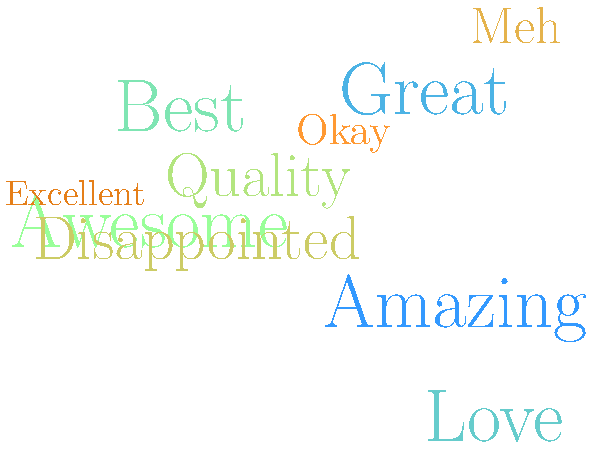As an intern researching trendy products for an influencer, you've conducted a brand sentiment analysis for a potential product collaboration. The word cloud above represents the most frequent words used in customer reviews. Which sentiment appears to be the most prominent, and how might this information guide your recommendation to the influencer? To answer this question, we need to analyze the word cloud systematically:

1. Identify the largest words: The most prominent words in a word cloud are typically represented by larger font sizes. In this case, "Amazing" and "Great" appear to be the largest.

2. Assess the overall sentiment: Most of the prominent words are positive (e.g., "Amazing", "Great", "Love", "Best", "Awesome", "Quality", "Excellent").

3. Note any negative sentiment: There are a few less prominent words with negative or neutral connotations (e.g., "Disappointed", "Meh", "Okay"), but they are smaller in size, indicating less frequency.

4. Interpret the results: The overwhelming presence of positive words, especially "Amazing" and "Great" being the largest, suggests that the overall sentiment towards this brand or product is very positive.

5. Consider the implications: For an influencer collaboration, a brand with strongly positive sentiment is likely to be well-received by the audience, potentially leading to successful promotion and maintaining the influencer's credibility.

Given this analysis, the most prominent sentiment is clearly positive, with "Amazing" being the standout word. This information would guide the recommendation to the influencer by suggesting that collaborating with this brand could be beneficial due to the existing positive perception among consumers.
Answer: Positive sentiment, suggesting a favorable brand collaboration opportunity 